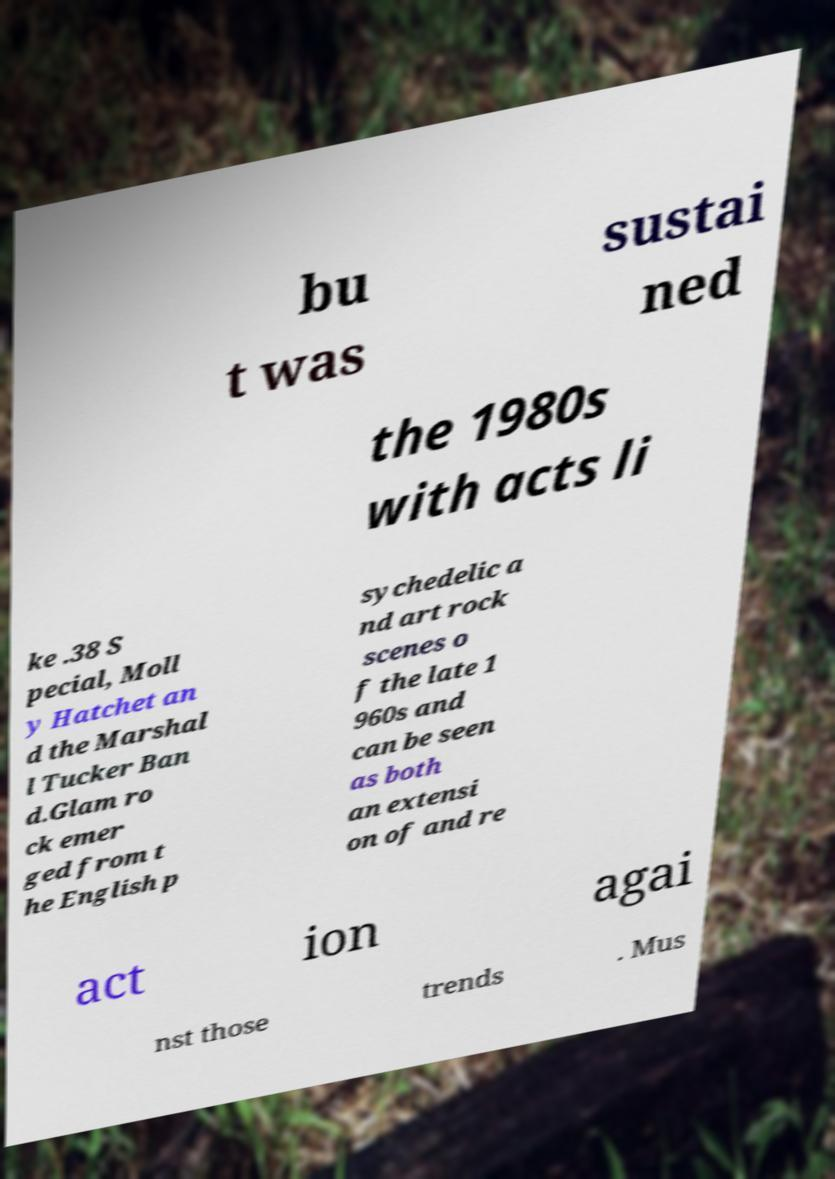Can you accurately transcribe the text from the provided image for me? bu t was sustai ned the 1980s with acts li ke .38 S pecial, Moll y Hatchet an d the Marshal l Tucker Ban d.Glam ro ck emer ged from t he English p sychedelic a nd art rock scenes o f the late 1 960s and can be seen as both an extensi on of and re act ion agai nst those trends . Mus 